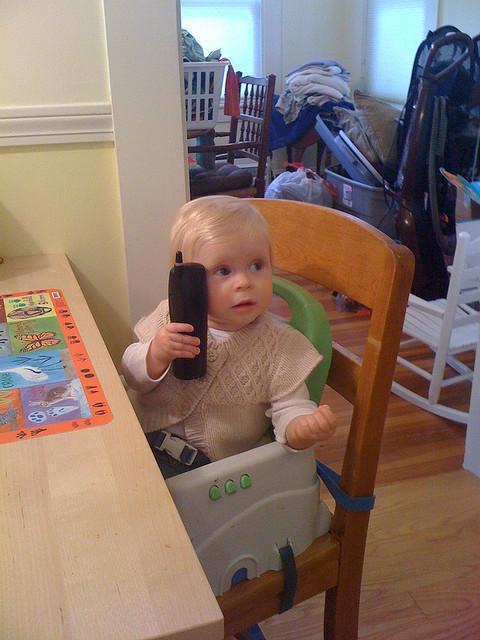Whos number did the child dial?
Pick the correct solution from the four options below to address the question.
Options: No ones, mom, dad, her own. No ones. 